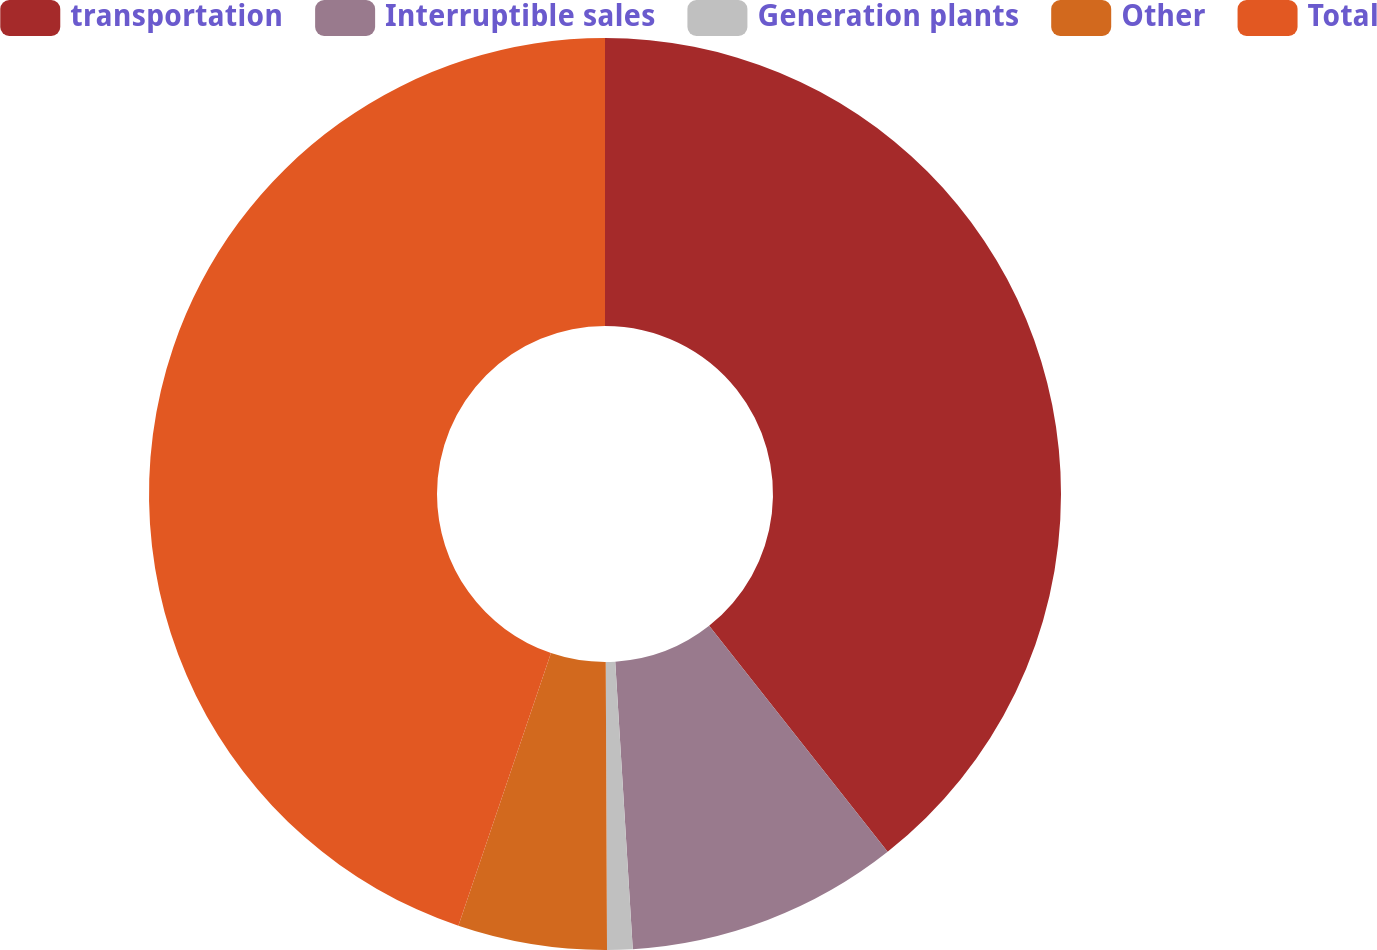Convert chart. <chart><loc_0><loc_0><loc_500><loc_500><pie_chart><fcel>transportation<fcel>Interruptible sales<fcel>Generation plants<fcel>Other<fcel>Total<nl><fcel>39.36%<fcel>9.67%<fcel>0.9%<fcel>5.28%<fcel>44.79%<nl></chart> 